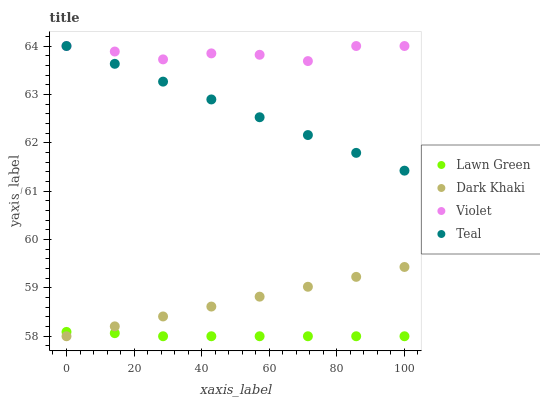Does Lawn Green have the minimum area under the curve?
Answer yes or no. Yes. Does Violet have the maximum area under the curve?
Answer yes or no. Yes. Does Teal have the minimum area under the curve?
Answer yes or no. No. Does Teal have the maximum area under the curve?
Answer yes or no. No. Is Teal the smoothest?
Answer yes or no. Yes. Is Violet the roughest?
Answer yes or no. Yes. Is Lawn Green the smoothest?
Answer yes or no. No. Is Lawn Green the roughest?
Answer yes or no. No. Does Dark Khaki have the lowest value?
Answer yes or no. Yes. Does Teal have the lowest value?
Answer yes or no. No. Does Violet have the highest value?
Answer yes or no. Yes. Does Lawn Green have the highest value?
Answer yes or no. No. Is Lawn Green less than Violet?
Answer yes or no. Yes. Is Violet greater than Lawn Green?
Answer yes or no. Yes. Does Teal intersect Violet?
Answer yes or no. Yes. Is Teal less than Violet?
Answer yes or no. No. Is Teal greater than Violet?
Answer yes or no. No. Does Lawn Green intersect Violet?
Answer yes or no. No. 